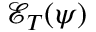<formula> <loc_0><loc_0><loc_500><loc_500>\mathcal { E } _ { T } ( \psi )</formula> 